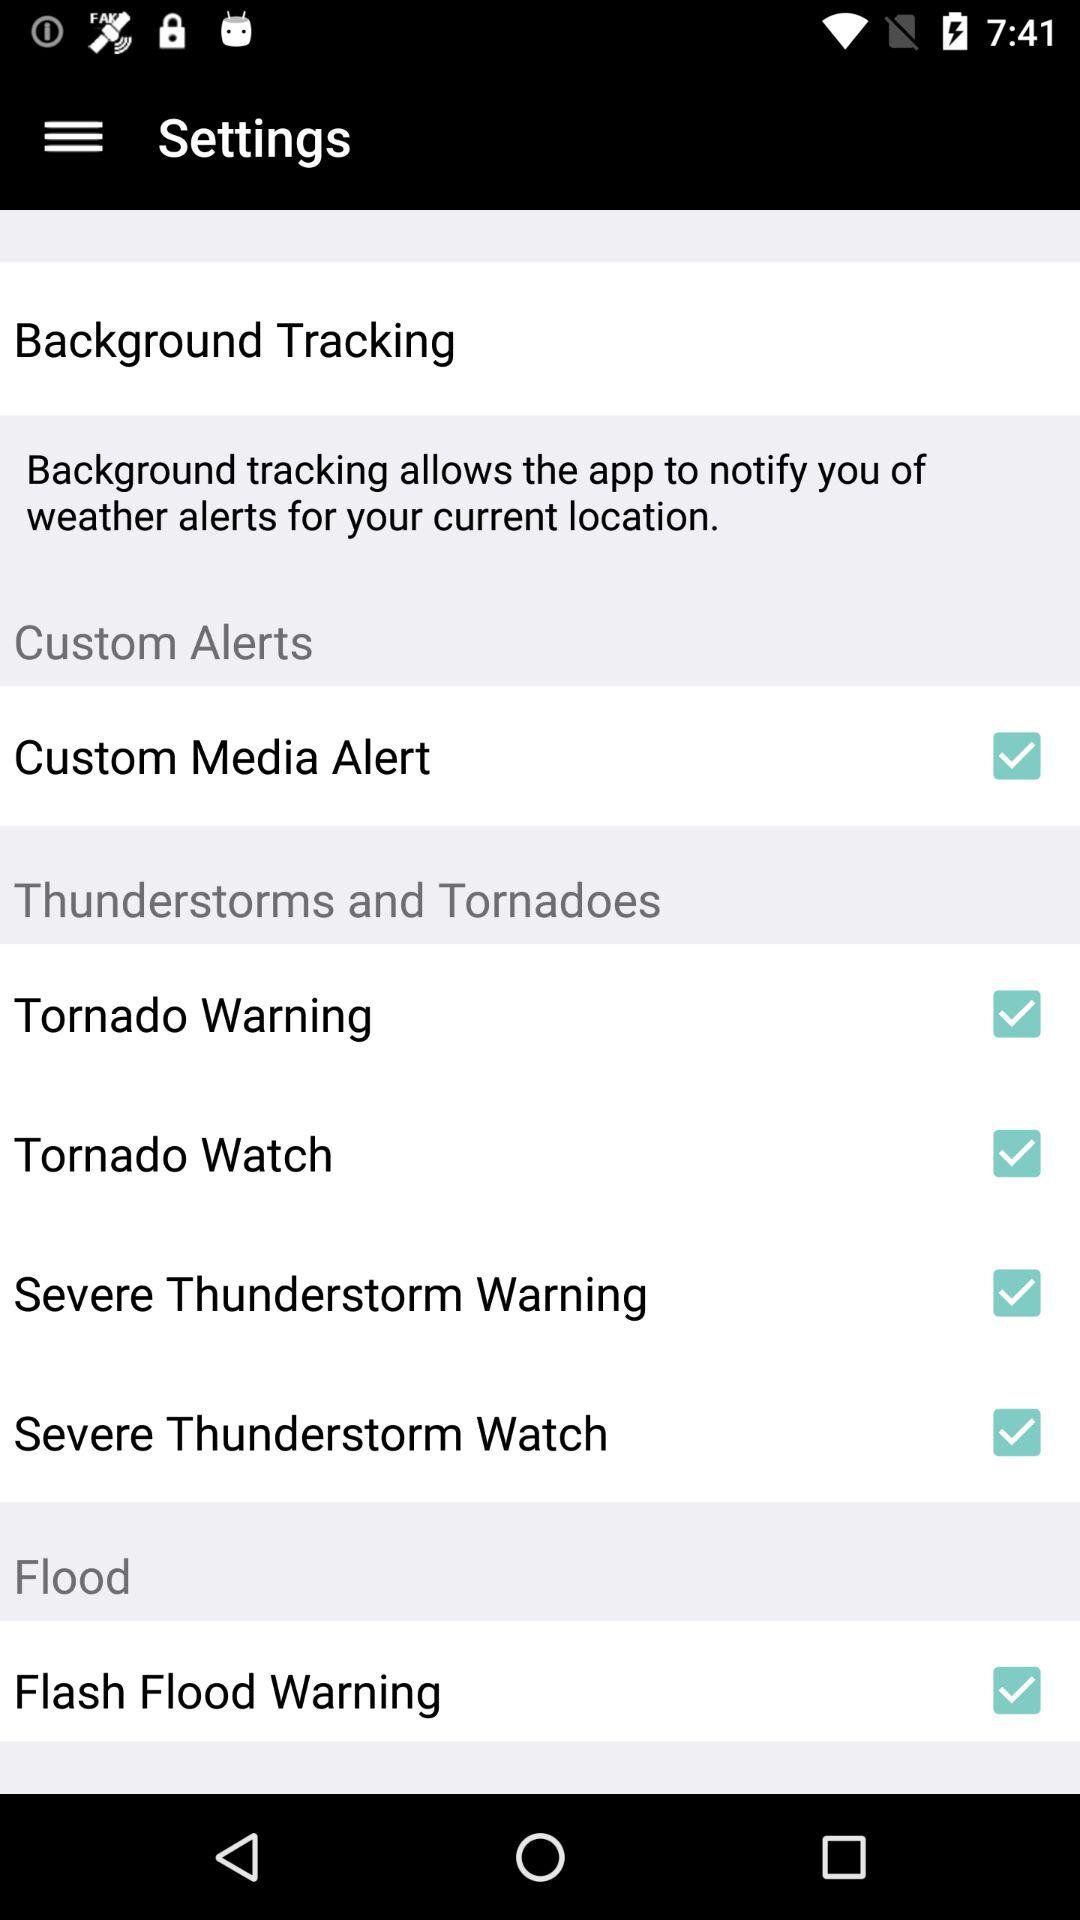What is the current status of "Flash Flood Warning"? The current status is "on". 